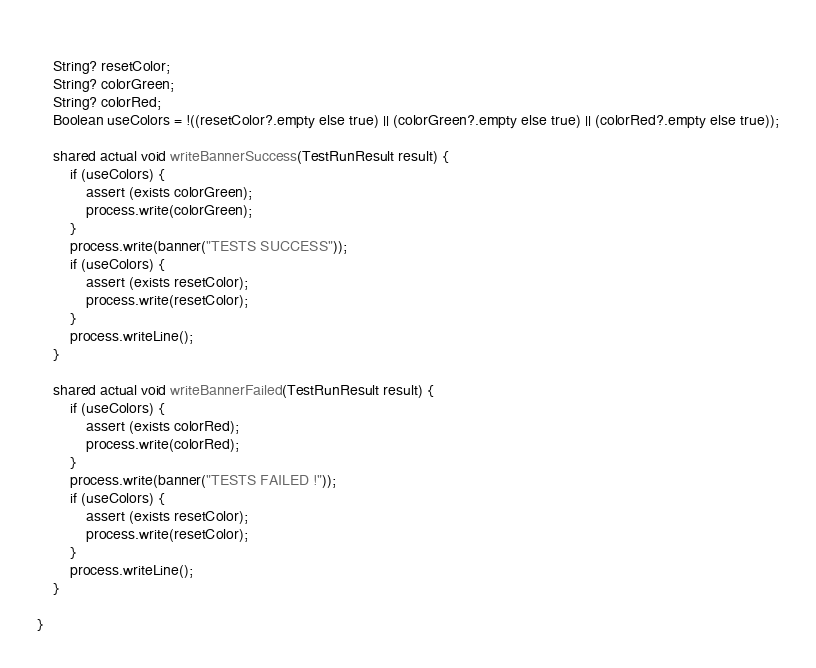<code> <loc_0><loc_0><loc_500><loc_500><_Ceylon_>    
    String? resetColor;
    String? colorGreen;
    String? colorRed;
    Boolean useColors = !((resetColor?.empty else true) || (colorGreen?.empty else true) || (colorRed?.empty else true));
    
    shared actual void writeBannerSuccess(TestRunResult result) {
        if (useColors) {
            assert (exists colorGreen);
            process.write(colorGreen);
        }
        process.write(banner("TESTS SUCCESS"));
        if (useColors) {
            assert (exists resetColor);
            process.write(resetColor);
        }
        process.writeLine();
    }
    
    shared actual void writeBannerFailed(TestRunResult result) {
        if (useColors) {
            assert (exists colorRed);
            process.write(colorRed);
        }
        process.write(banner("TESTS FAILED !"));
        if (useColors) {
            assert (exists resetColor);
            process.write(resetColor);
        }
        process.writeLine();
    }
    
}</code> 